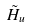<formula> <loc_0><loc_0><loc_500><loc_500>\tilde { H } _ { u }</formula> 